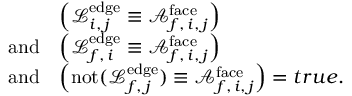<formula> <loc_0><loc_0><loc_500><loc_500>\begin{array} { r l } & { \left ( \mathcal { L } _ { i , \, j } ^ { e d g e } \equiv \mathcal { A } _ { f , \, i , \, j } ^ { f a c e } \right ) } \\ { a n d } & { \left ( \mathcal { L } _ { f , \, i } ^ { e d g e } \equiv \mathcal { A } _ { f , \, i , \, j } ^ { f a c e } \right ) } \\ { a n d } & { \left ( n o t ( \mathcal { L } _ { f , \, j } ^ { e d g e } ) \equiv \mathcal { A } _ { f , \, i , \, j } ^ { f a c e } \right ) = t r u e . } \end{array}</formula> 